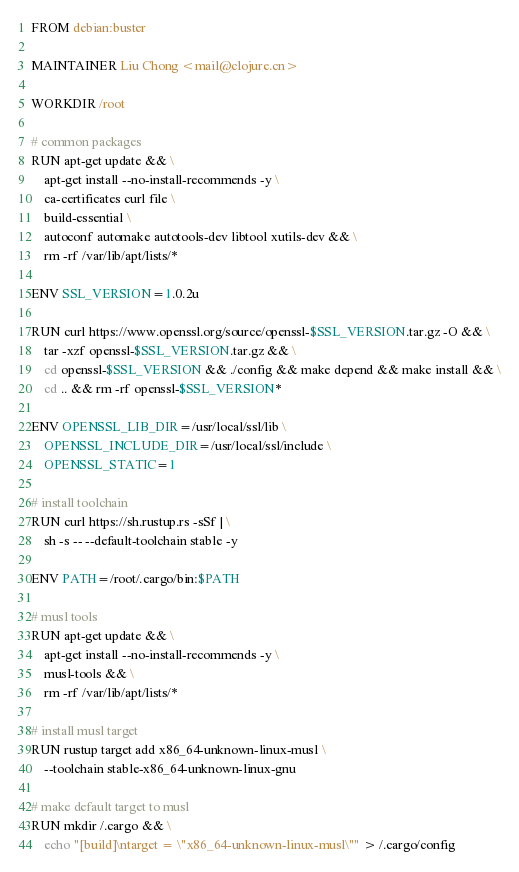<code> <loc_0><loc_0><loc_500><loc_500><_Dockerfile_>FROM debian:buster

MAINTAINER Liu Chong <mail@clojure.cn>

WORKDIR /root

# common packages
RUN apt-get update && \
    apt-get install --no-install-recommends -y \
    ca-certificates curl file \
    build-essential \
    autoconf automake autotools-dev libtool xutils-dev && \
    rm -rf /var/lib/apt/lists/*

ENV SSL_VERSION=1.0.2u

RUN curl https://www.openssl.org/source/openssl-$SSL_VERSION.tar.gz -O && \
    tar -xzf openssl-$SSL_VERSION.tar.gz && \
    cd openssl-$SSL_VERSION && ./config && make depend && make install && \
    cd .. && rm -rf openssl-$SSL_VERSION*

ENV OPENSSL_LIB_DIR=/usr/local/ssl/lib \
    OPENSSL_INCLUDE_DIR=/usr/local/ssl/include \
    OPENSSL_STATIC=1

# install toolchain
RUN curl https://sh.rustup.rs -sSf | \
    sh -s -- --default-toolchain stable -y

ENV PATH=/root/.cargo/bin:$PATH

# musl tools
RUN apt-get update && \
    apt-get install --no-install-recommends -y \
    musl-tools && \
    rm -rf /var/lib/apt/lists/*

# install musl target
RUN rustup target add x86_64-unknown-linux-musl \
    --toolchain stable-x86_64-unknown-linux-gnu

# make default target to musl
RUN mkdir /.cargo && \
    echo "[build]\ntarget = \"x86_64-unknown-linux-musl\"" > /.cargo/config
</code> 